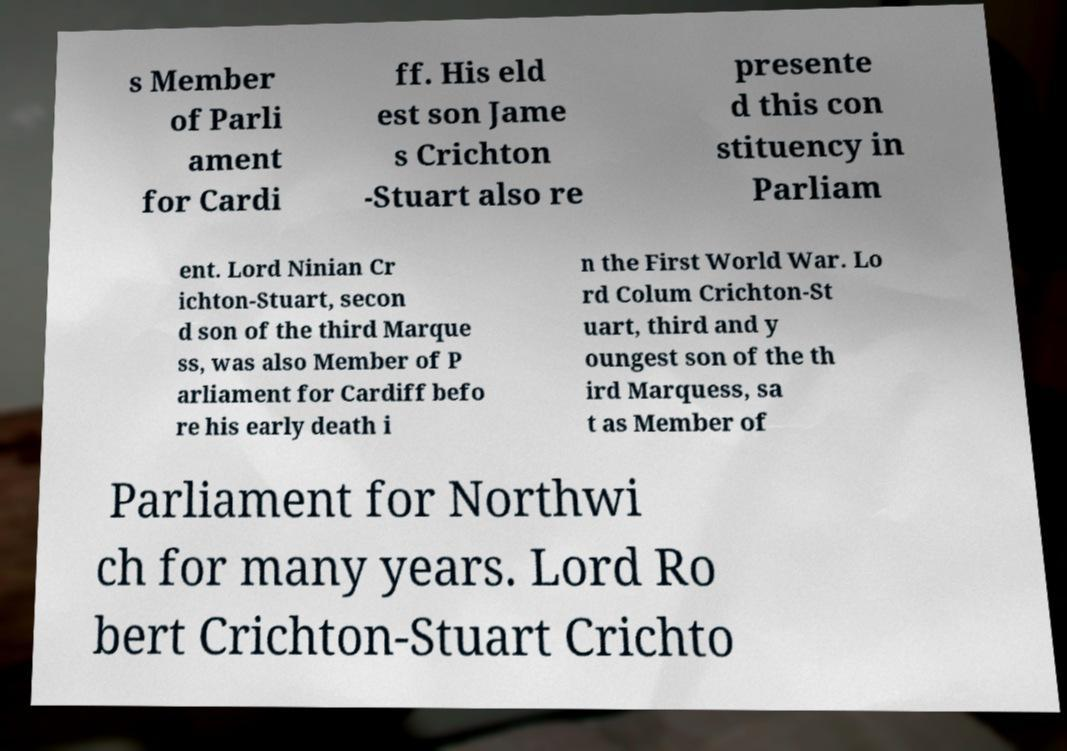Please read and relay the text visible in this image. What does it say? s Member of Parli ament for Cardi ff. His eld est son Jame s Crichton -Stuart also re presente d this con stituency in Parliam ent. Lord Ninian Cr ichton-Stuart, secon d son of the third Marque ss, was also Member of P arliament for Cardiff befo re his early death i n the First World War. Lo rd Colum Crichton-St uart, third and y oungest son of the th ird Marquess, sa t as Member of Parliament for Northwi ch for many years. Lord Ro bert Crichton-Stuart Crichto 